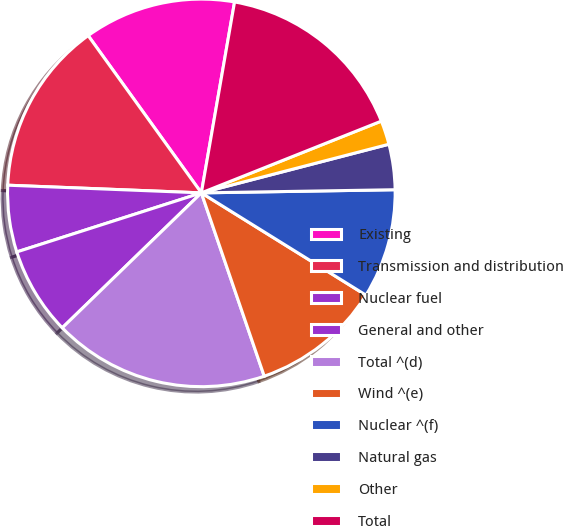Convert chart. <chart><loc_0><loc_0><loc_500><loc_500><pie_chart><fcel>Existing<fcel>Transmission and distribution<fcel>Nuclear fuel<fcel>General and other<fcel>Total ^(d)<fcel>Wind ^(e)<fcel>Nuclear ^(f)<fcel>Natural gas<fcel>Other<fcel>Total<nl><fcel>12.67%<fcel>14.44%<fcel>5.56%<fcel>7.33%<fcel>18.0%<fcel>10.89%<fcel>9.11%<fcel>3.78%<fcel>2.0%<fcel>16.22%<nl></chart> 